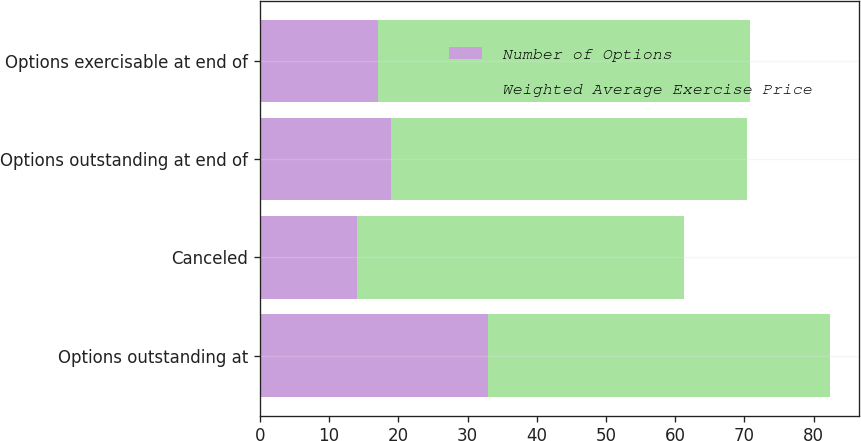Convert chart to OTSL. <chart><loc_0><loc_0><loc_500><loc_500><stacked_bar_chart><ecel><fcel>Options outstanding at<fcel>Canceled<fcel>Options outstanding at end of<fcel>Options exercisable at end of<nl><fcel>Number of Options<fcel>33<fcel>14<fcel>19<fcel>17<nl><fcel>Weighted Average Exercise Price<fcel>49.4<fcel>47.29<fcel>51.3<fcel>53.86<nl></chart> 